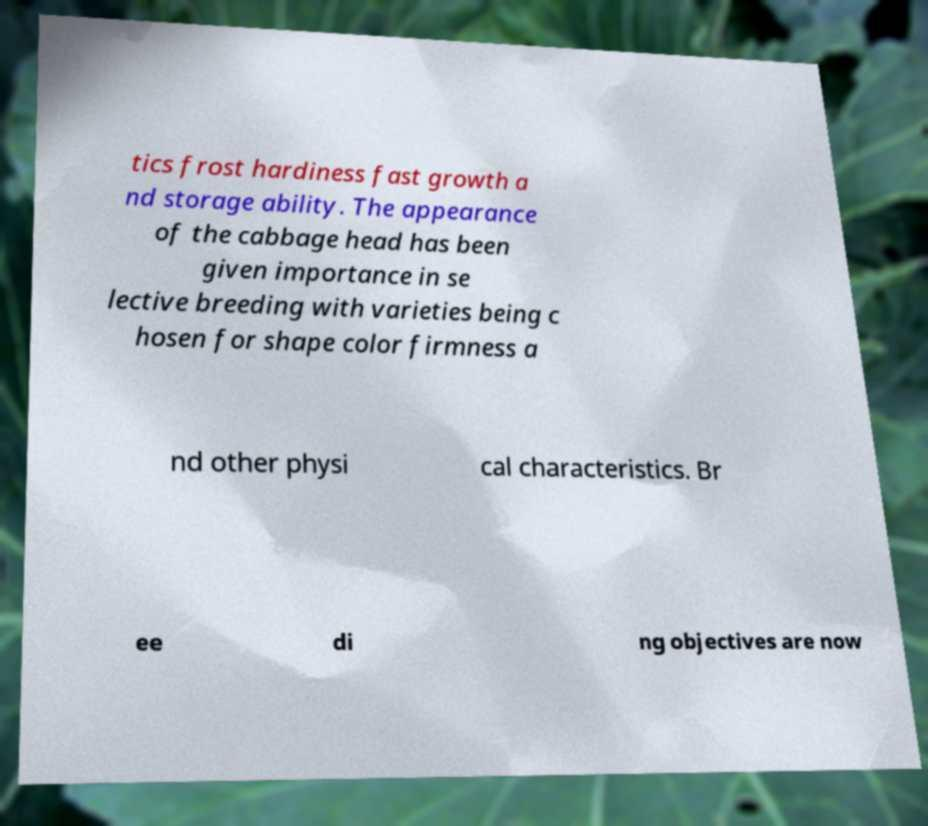Could you extract and type out the text from this image? tics frost hardiness fast growth a nd storage ability. The appearance of the cabbage head has been given importance in se lective breeding with varieties being c hosen for shape color firmness a nd other physi cal characteristics. Br ee di ng objectives are now 